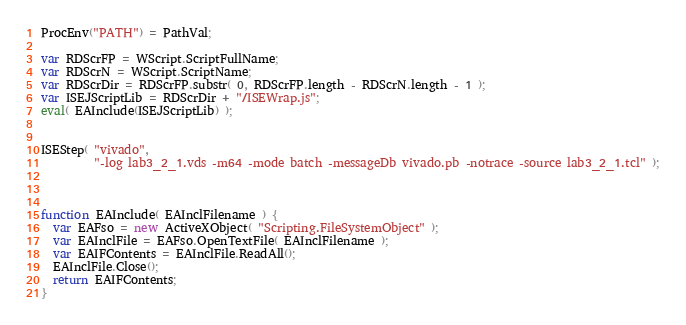<code> <loc_0><loc_0><loc_500><loc_500><_JavaScript_>
ProcEnv("PATH") = PathVal;

var RDScrFP = WScript.ScriptFullName;
var RDScrN = WScript.ScriptName;
var RDScrDir = RDScrFP.substr( 0, RDScrFP.length - RDScrN.length - 1 );
var ISEJScriptLib = RDScrDir + "/ISEWrap.js";
eval( EAInclude(ISEJScriptLib) );


ISEStep( "vivado",
         "-log lab3_2_1.vds -m64 -mode batch -messageDb vivado.pb -notrace -source lab3_2_1.tcl" );



function EAInclude( EAInclFilename ) {
  var EAFso = new ActiveXObject( "Scripting.FileSystemObject" );
  var EAInclFile = EAFso.OpenTextFile( EAInclFilename );
  var EAIFContents = EAInclFile.ReadAll();
  EAInclFile.Close();
  return EAIFContents;
}
</code> 